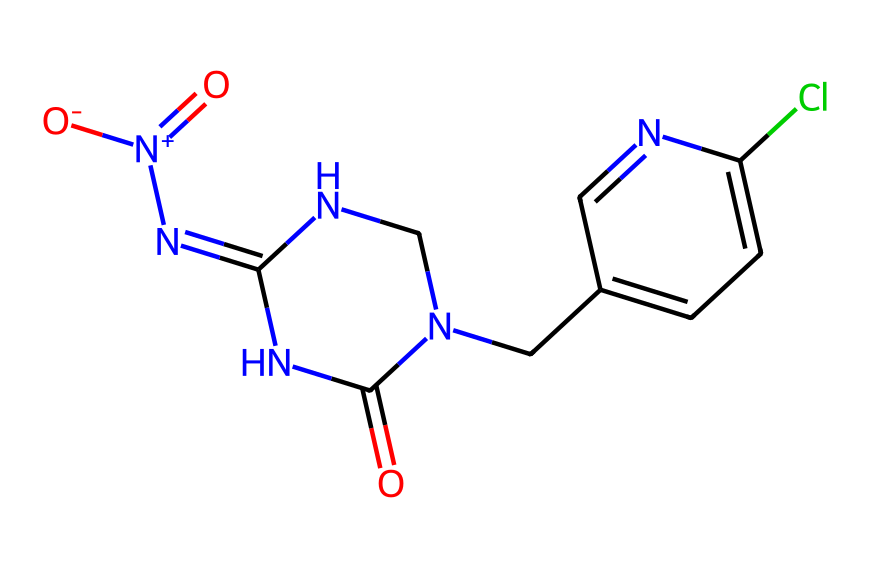What is the molecular formula of this chemical? To determine the molecular formula, count the atoms of each element present in the structure based on the SMILES representation. The SMILES indicates there are 10 carbon atoms (C), 12 hydrogen atoms (H), 3 nitrogen atoms (N), 1 oxygen atom (O), and 1 chlorine atom (Cl), which gives the molecular formula C10H12ClN5O2.
Answer: C10H12ClN5O2 How many nitrogen atoms are present? The SMILES shows three 'N' symbols, indicating there are three nitrogen atoms in the structure.
Answer: 3 What type of chemical structure is indicated by this compound? Neonicotinoids are characterized by their structure which includes a nitrogen-containing bicyclic ring (specifically an imidazolidine ring), common in insecticides. The presence of nitrogen atoms and the specific arrangement correlate with the neonicotinoid classification.
Answer: neonicotinoid What functional groups can be identified in this structure? The structure contains a nitro group (indicated by '[N+](=O)[O-]') and a carbonyl group (indicated by 'O=C'), which are both important functional groups for the activity of neonicotinoids in agriculture.
Answer: nitro and carbonyl Does this chemical contain halogens? The presence of the 'Cl' in the SMILES indicates that there is chlorine in the structure, which is a halogen.
Answer: yes How does this compound interact with target pests? Neonicotinoids, such as this compound, act on the nervous system of insects by binding to nicotinic acetylcholine receptors, leading to paralysis and death. This mechanism is supported by the structural similarity to acetylcholine, which the compound's nitrogen atoms facilitate.
Answer: binds to nicotinic receptors 